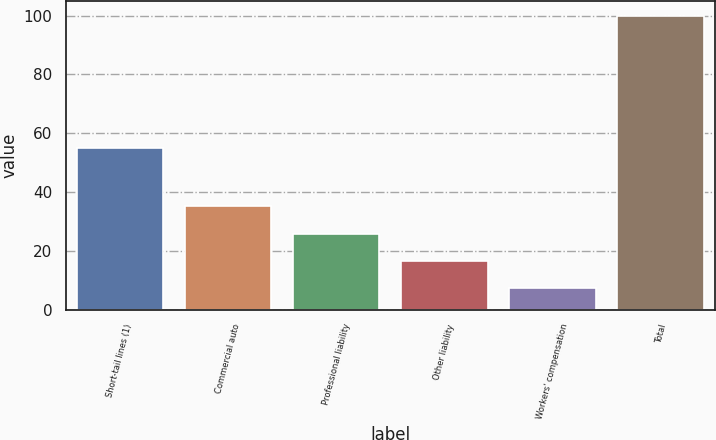Convert chart. <chart><loc_0><loc_0><loc_500><loc_500><bar_chart><fcel>Short-tail lines (1)<fcel>Commercial auto<fcel>Professional liability<fcel>Other liability<fcel>Workers' compensation<fcel>Total<nl><fcel>55.1<fcel>35.11<fcel>25.84<fcel>16.57<fcel>7.3<fcel>100<nl></chart> 